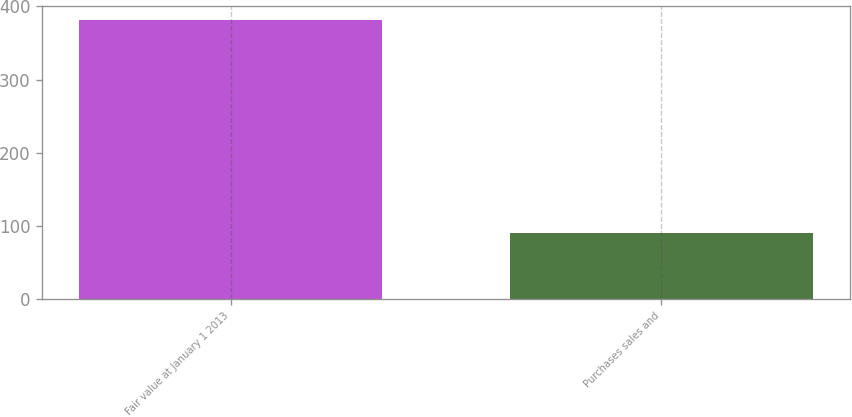Convert chart. <chart><loc_0><loc_0><loc_500><loc_500><bar_chart><fcel>Fair value at January 1 2013<fcel>Purchases sales and<nl><fcel>381<fcel>91<nl></chart> 